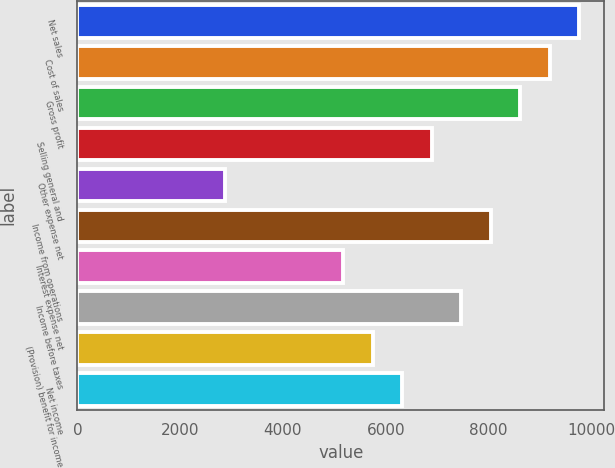Convert chart to OTSL. <chart><loc_0><loc_0><loc_500><loc_500><bar_chart><fcel>Net sales<fcel>Cost of sales<fcel>Gross profit<fcel>Selling general and<fcel>Other expense net<fcel>Income from operations<fcel>Interest expense net<fcel>Income before taxes<fcel>(Provision) benefit for income<fcel>Net income<nl><fcel>9759.35<fcel>9185.4<fcel>8611.45<fcel>6889.6<fcel>2871.95<fcel>8037.5<fcel>5167.75<fcel>7463.55<fcel>5741.7<fcel>6315.65<nl></chart> 